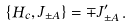Convert formula to latex. <formula><loc_0><loc_0><loc_500><loc_500>\left \{ H _ { c } , J _ { \pm A } \right \} = \mp J ^ { \prime } _ { \pm A } \, .</formula> 